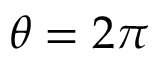Convert formula to latex. <formula><loc_0><loc_0><loc_500><loc_500>\theta = 2 \pi</formula> 